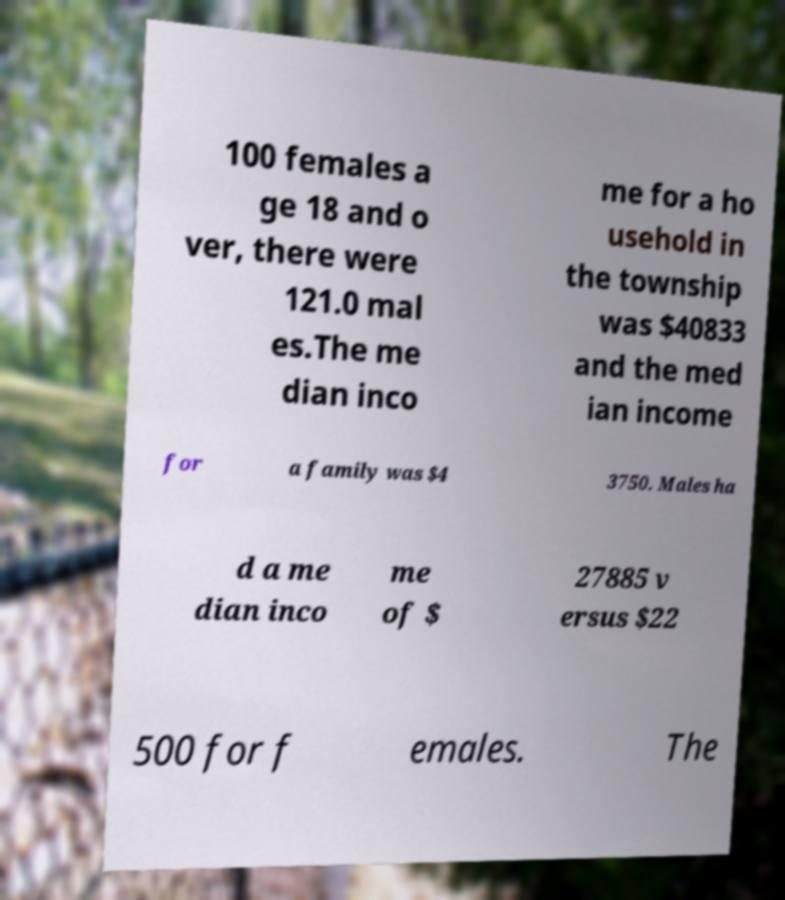Please read and relay the text visible in this image. What does it say? 100 females a ge 18 and o ver, there were 121.0 mal es.The me dian inco me for a ho usehold in the township was $40833 and the med ian income for a family was $4 3750. Males ha d a me dian inco me of $ 27885 v ersus $22 500 for f emales. The 